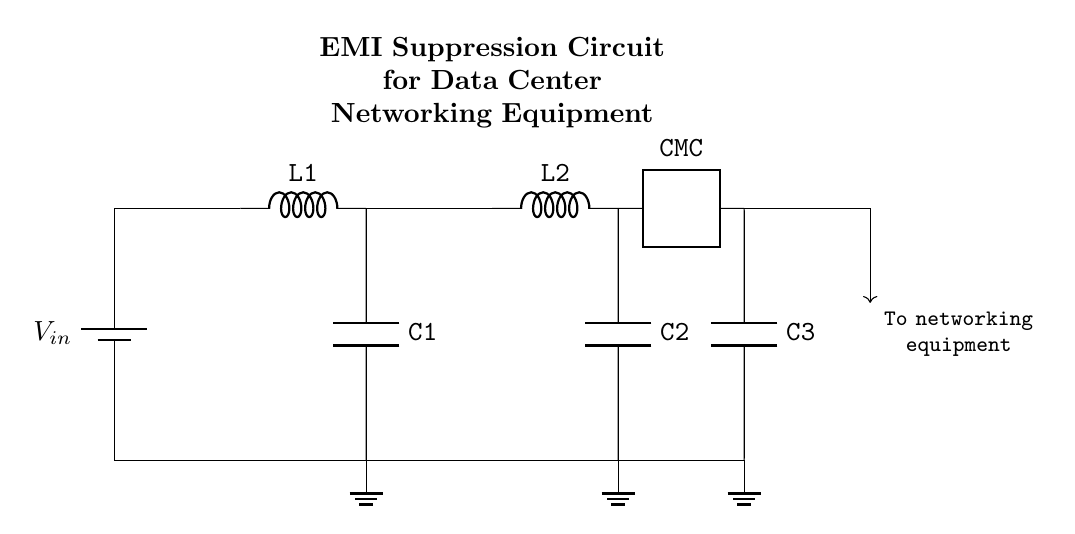What is the input voltage of this circuit? The input voltage is denoted by the symbol V in the circuit diagram and is connected to the battery symbol, indicating the voltage source for the circuit.
Answer: V in What type of components are L1 and L2? L1 and L2 are inductors, which are identified by the 'L' label next to them in the circuit diagram. Inductors are used to filter high-frequency noise in EMI suppression circuits.
Answer: Inductors What is the function of the common mode choke (CMC)? The common mode choke is a two-port component that reduces electromagnetic interference by suppressing common mode noise. This is validated by its connection and labeling in the diagram.
Answer: Noise suppression How many capacitors are present in this circuit? The diagram contains three capacitors labeled C1, C2, and C3, which are visually shown interconnected at different points in the circuit.
Answer: Three What is the purpose of the capacitors C1 and C2 in the circuit? Capacitors C1 and C2 are used for filtering high-frequency noise. Their positions after the inductors indicate they are linked to decoupling and EMI suppression, allowing unwanted frequencies to be bypassed to ground.
Answer: EMI filtering What is the role of the ground connections in the circuit? The ground connections provide a reference point for the voltages and safe return path for unwanted currents, which is crucial for the stable operation of the circuit and to prevent floating voltages.
Answer: Reference point What type of circuit is this overall? This circuit is classified as an EMI suppression circuit, specifically designed for data center networking equipment to reduce interference that could disrupt signal integrity.
Answer: EMI suppression circuit 